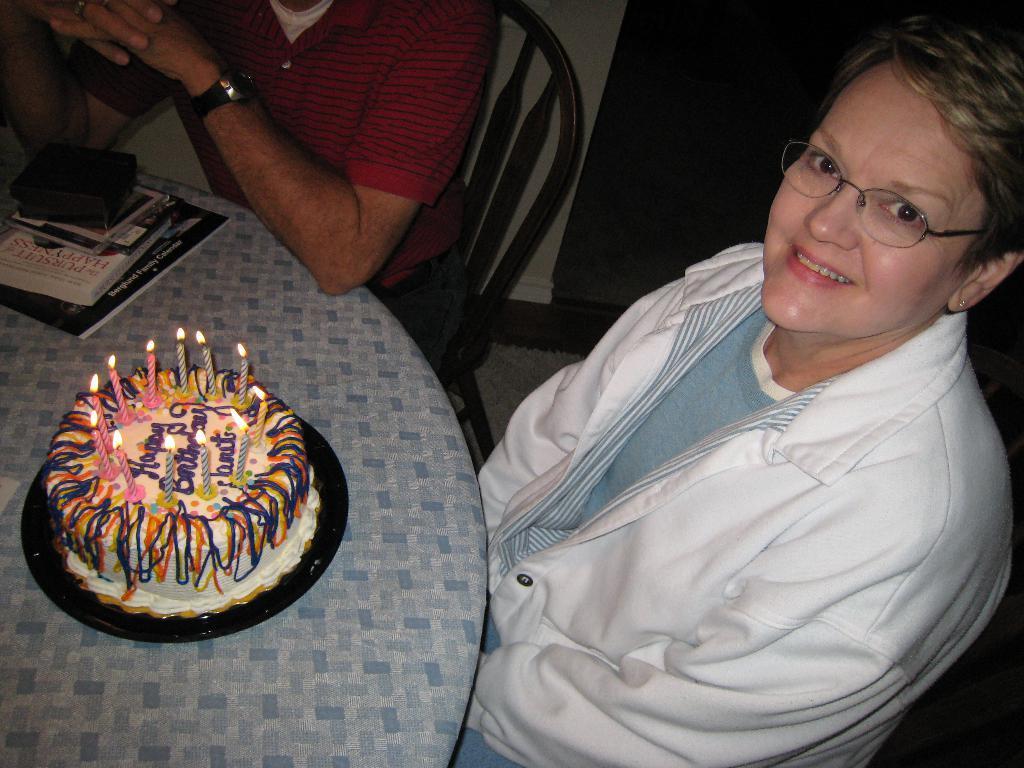In one or two sentences, can you explain what this image depicts? Here in this picture, in the front we can see a woman and a man sitting on chairs and in front of them we can see a table, on which we can see a cake with candles present on it and we can also see some books present and we can see the woman is smiling and wearing spectacles. 